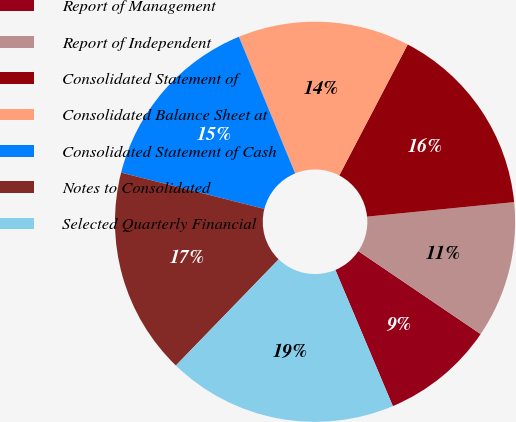Convert chart. <chart><loc_0><loc_0><loc_500><loc_500><pie_chart><fcel>Report of Management<fcel>Report of Independent<fcel>Consolidated Statement of<fcel>Consolidated Balance Sheet at<fcel>Consolidated Statement of Cash<fcel>Notes to Consolidated<fcel>Selected Quarterly Financial<nl><fcel>9.16%<fcel>11.05%<fcel>15.77%<fcel>13.88%<fcel>14.83%<fcel>16.71%<fcel>18.6%<nl></chart> 